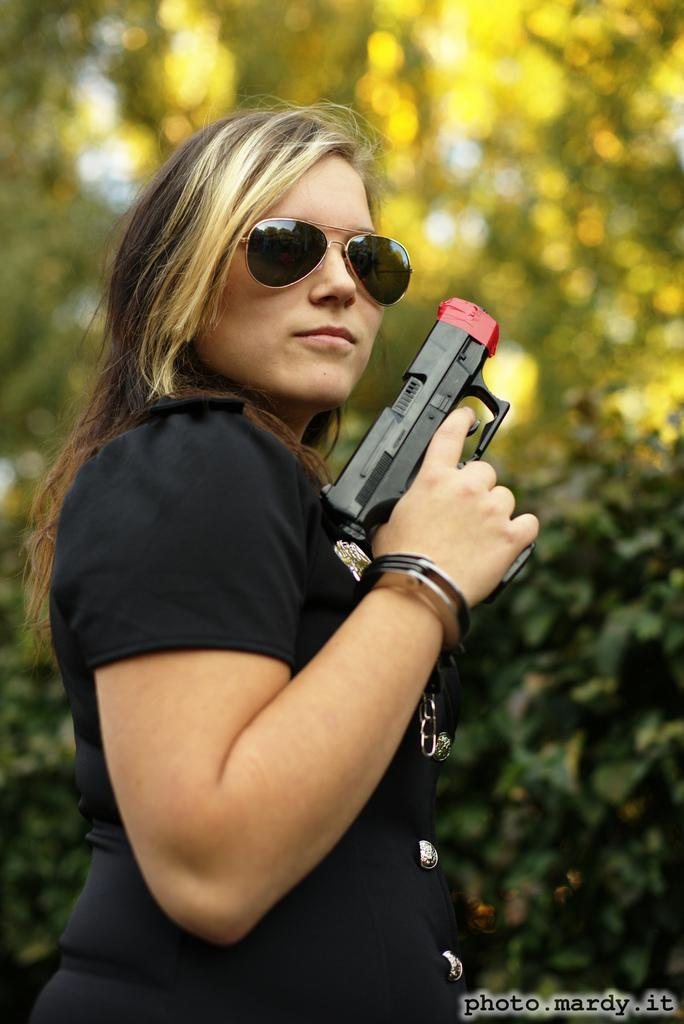What is the person in the image holding? The person is holding a gun in the image. What can be found at the bottom of the image? There is text at the bottom of the image. What type of natural scenery is visible in the background? There are trees in the background of the image. What type of coal is being mined in the image? There is no coal or mining activity present in the image. What does the caption at the bottom of the image say? The provided facts do not mention the content of the text at the bottom of the image, so we cannot answer this question. 